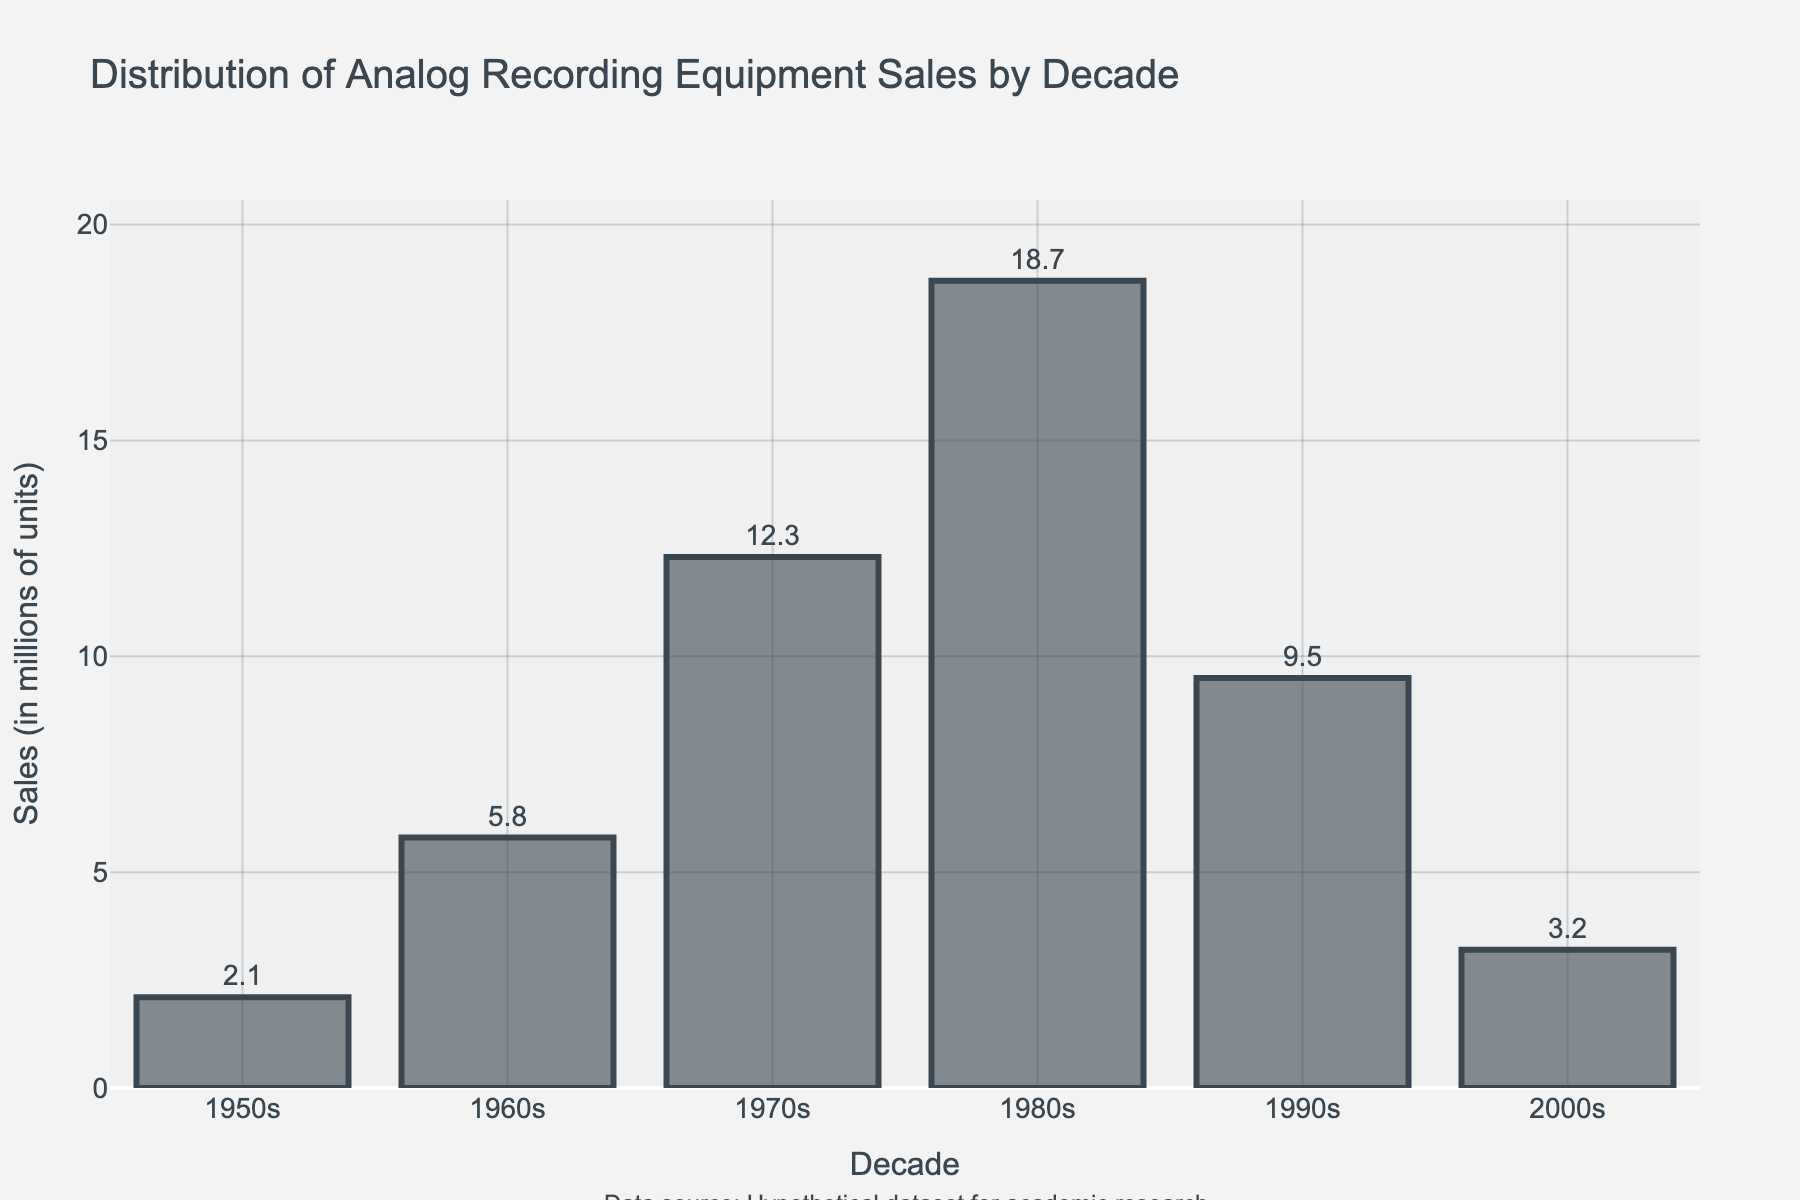What decade saw the highest sales of analog recording equipment? We look at the bar heights to identify the highest bar, representing sales. The 1980s bar is the tallest, indicating the highest sales.
Answer: 1980s How many decades had sales above 10 million units? The bars for the 1970s, 1980s, and 1990s are above the 10 million units mark. Count these decades.
Answer: 3 What is the total sales of analog recording equipment from the 1950s to the 2000s? Sum the sales figures for all decades: 2.1 + 5.8 + 12.3 + 18.7 + 9.5 + 3.2
Answer: 51.6 million units In which decade did sales decline the most compared to the previous decade? Calculate the sales decrease between consecutive decades and identify the largest drop: 1990s to 2000s is the largest with 6.3 million units (9.5 - 3.2).
Answer: 1990s to 2000s Which decade had sales closest to the median value of all decades? Arrange the sales in ascending order (2.1, 3.2, 5.8, 9.5, 12.3, 18.7) and find the median, which is the average of 5.8 and 9.5, so 7.65. The 1990s, closest to this median with 9.5 million units, is the answer.
Answer: 1990s Compare the combined sales of the 1950s and 1960s with the sales in the 1970s. Which is higher? Sum the sales for the 1950s and 1960s (2.1 + 5.8 = 7.9) and compare with the 1970s (12.3). The 1970s sales are higher.
Answer: 1970s What is the average sales per decade across the observed period? Sum the sales figures (2.1 + 5.8 + 12.3 + 18.7 + 9.5 + 3.2 = 51.6) and divide by the number of decades (6).
Answer: 8.6 million units Which two decades have the most similar sales figures? Compare the sales figures of all the decades: The 1950s and 2000s are closest with 2.1 and 3.2 million units respectively. The difference is 1.1 million units.
Answer: 1950s and 2000s 